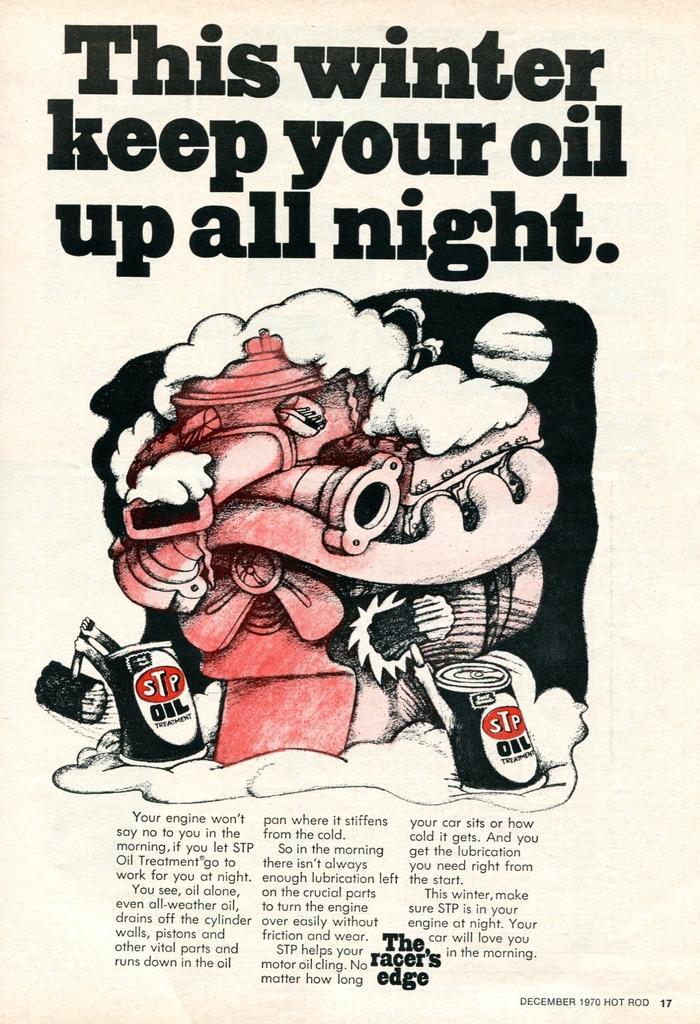Could you give a brief overview of what you see in this image? In the picture we can see a magazine with a cartoon image and some information under it. 